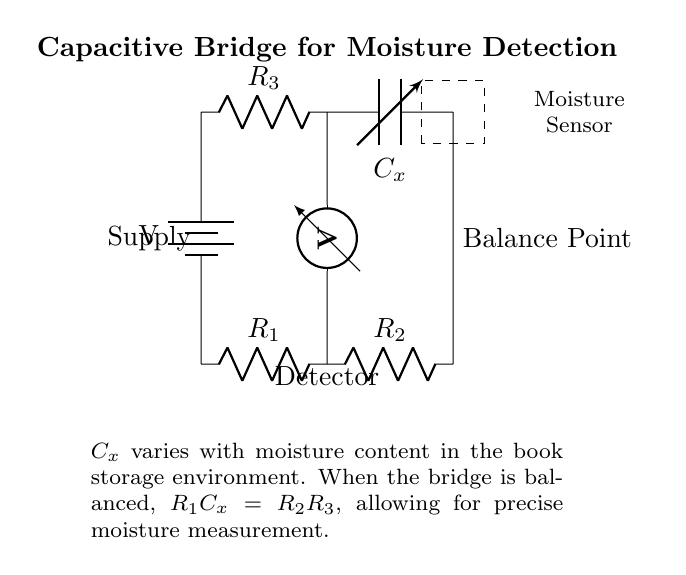What are the components in the upper arm of the bridge? The upper arm consists of a resistor labeled R3 and a variable capacitor labeled Cx.
Answer: R3, Cx What is the function of the detector in this circuit? The detector measures the voltage difference between the bridge arms to identify when the bridge is balanced, which is crucial for moisture content detection.
Answer: Measure voltage How is the balance point indicated in the circuit? The balance point is positioned at the juncture of the upper and lower arms of the bridge, signifying the point at which the voltage is equal, enabling accurate readings.
Answer: Balance Point What happens when the bridge is balanced? The condition $R1C_x = R2R3$ must hold true, indicating that the capacitance's response to moisture has equated the resistor values, allowing accurate moisture measurement.
Answer: R1C_x = R2R3 What affects the value of Cx in this circuit? Cx varies with the moisture content in the storage environment, which is directly related to how much moisture is present in the archival books.
Answer: Moisture content What is the power source in this circuit? The circuit is powered by a battery labeled V, providing the necessary voltage for its operation.
Answer: Battery 